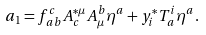Convert formula to latex. <formula><loc_0><loc_0><loc_500><loc_500>a _ { 1 } = f _ { \, a b } ^ { c } A _ { c } ^ { * \mu } A _ { \mu } ^ { b } \eta ^ { a } + y _ { i } ^ { * } T _ { \, a } ^ { i } \eta ^ { a } .</formula> 